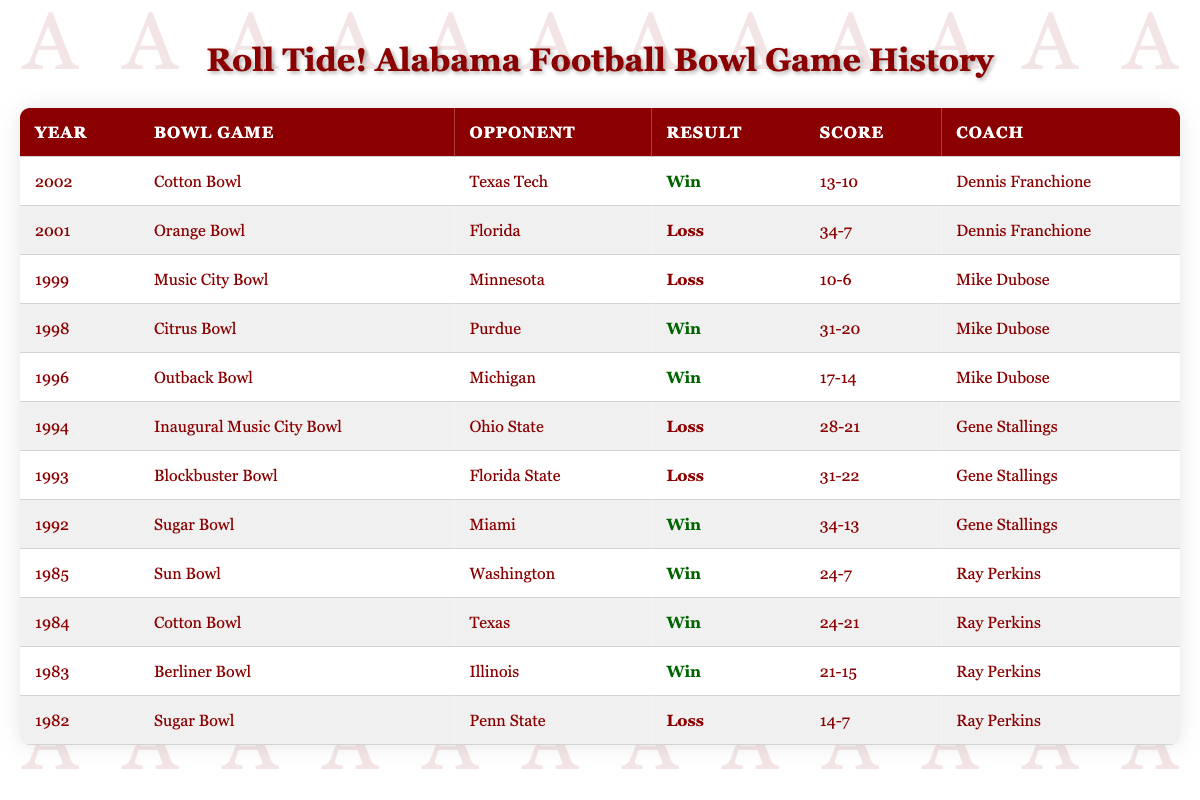What was the result of the 2002 Cotton Bowl? The 2002 Cotton Bowl featured Alabama against Texas Tech, and the result was a win for Alabama. This information can be found in the row for the year 2002, which clearly states "Win" in the Result column.
Answer: Win Who was the coach of Alabama during the 1992 Sugar Bowl? In the table, the row for the 1992 Sugar Bowl shows that the coach was Gene Stallings. You can locate this by finding the entry for the year 1992 and looking under the Coach column.
Answer: Gene Stallings How many bowl games did Alabama lose prior to the 2002 season? By counting the rows with "Loss" in the Result column, we see that Alabama lost four bowl games before the 2002 season: the 1982 Sugar Bowl, 1993 Blockbuster Bowl, 1994 Music City Bowl, and 2001 Orange Bowl. Therefore, the total losses are counted as 4.
Answer: 4 What is the average score of Alabama's bowl game results up to the 2002 season? First, take the scores of each game and convert them into numerical values: 7, 15, 21, 7, 34, 22, 21, 14, 20, 6, 7, and 10 from the scores column. Then, sum them up: (7 + 15 + 21 + 7 + 34 + 22 + 21 + 14 + 20 + 6 + 7 + 10) =  14 + 20 + 6 + 7 + 10 =  5; the total score is 253. Next, we have 12 games in total, so compute the average by dividing the total score by the number of games: 253 divided by 12 equals approximately 21.08.
Answer: 21.08 Did Alabama win more bowl games or lose more up to the 2002 season? To answer this, we need to count both the "Win" and "Loss" results from the table. There are 8 wins (counting the number of rows with "Win") and 4 losses. Since 8 is greater than 4, we can conclude that Alabama won more bowl games than it lost.
Answer: Yes, more wins What was the score difference in the 1993 Blockbuster Bowl? In the 1993 Blockbuster Bowl, Alabama lost with a score of 31-22. To find the score difference, subtract the losing score from the winning score: 31 - 22 = 9. This indicates the extent of the loss.
Answer: 9 Which opponent did Alabama defeat in the Cotton Bowl in 1984? Looking at the 1984 Cotton Bowl entry in the table, it specifies that the opponent was Texas. This direct comparison can be found in the column marked Opponent for the 1984 game.
Answer: Texas How many different coaches did Alabama have in bowl games prior to 2002? By examining the Coach column and counting the distinct names, we can identify Ray Perkins, Gene Stallings, Mike Dubose, and Dennis Franchione. This totals 4 unique coaches involved in the bowl games before the 2002 season.
Answer: 4 